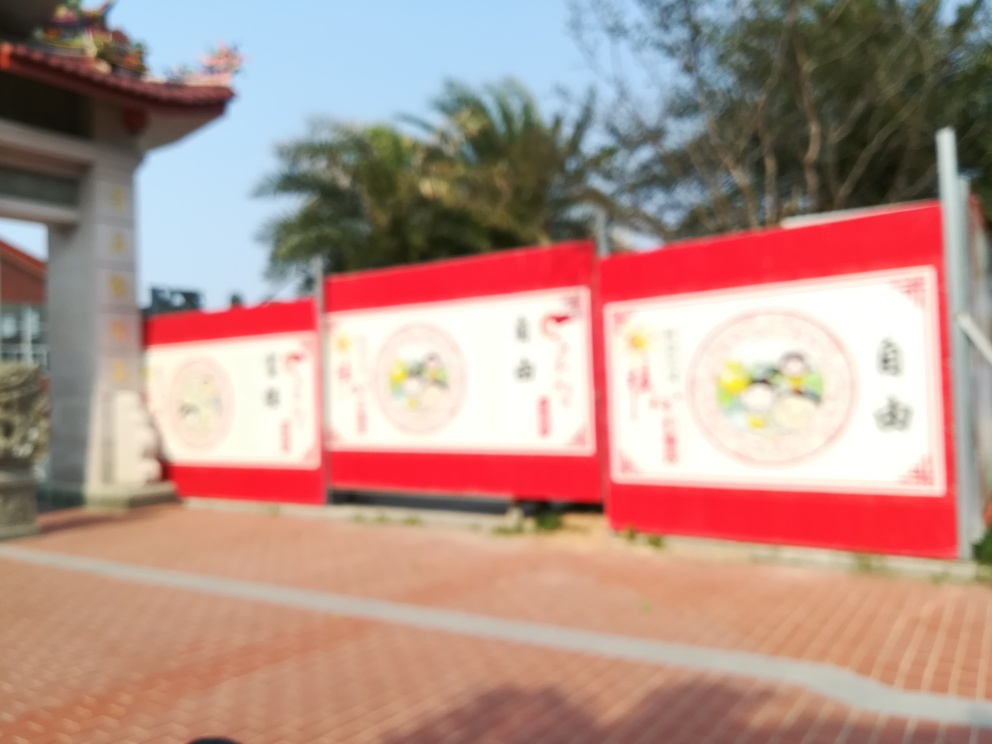Is the advertising billboard in focus?
A. No
B. Yes
Answer with the option's letter from the given choices directly.
 A. 